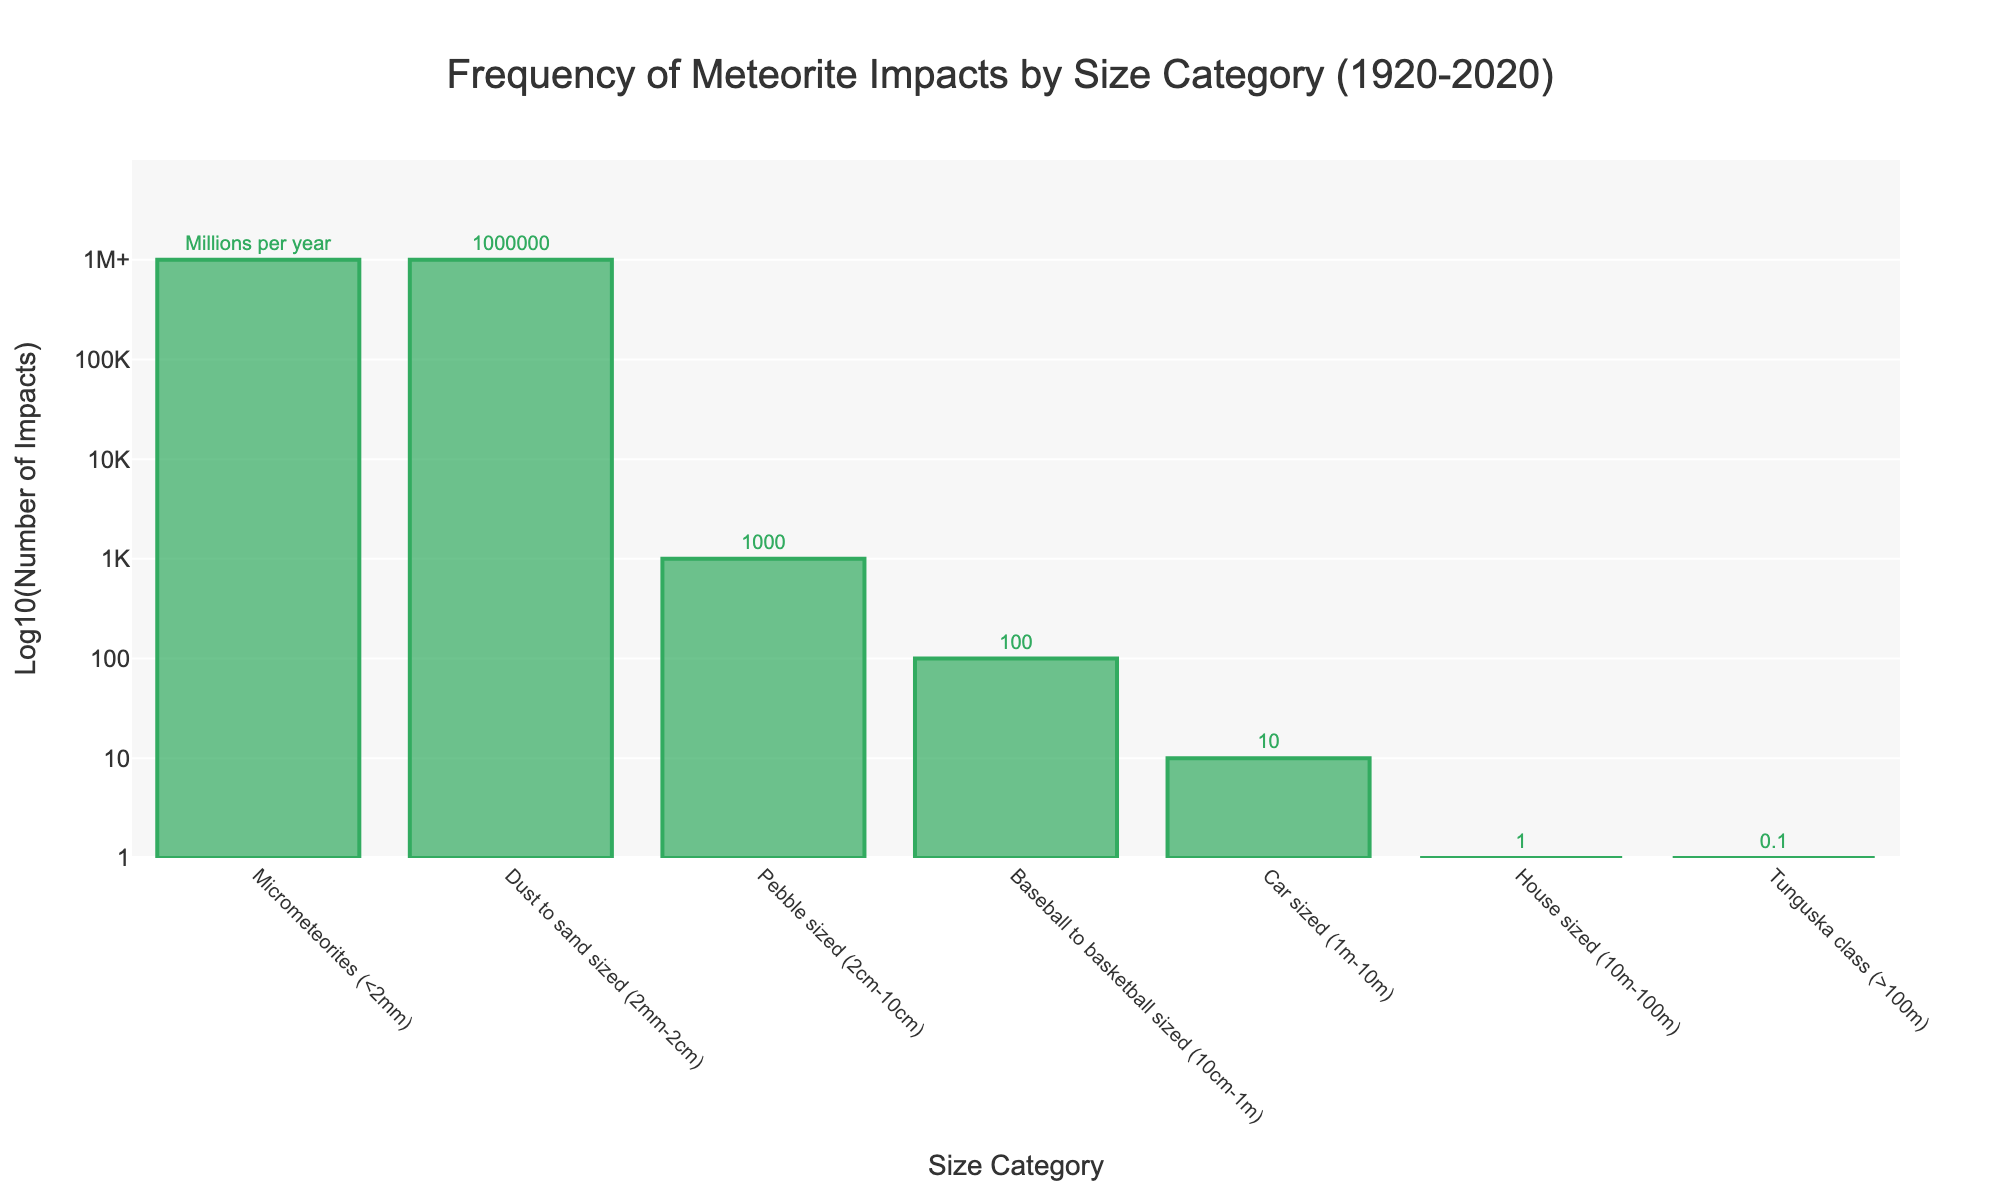What's the most frequent size category of meteorite impacts? The most frequent size category corresponds to the tallest bar in the chart, which represents micrometeorites (<2mm). The chart labels indicate this category experiences occurrences in the millions per year.
Answer: Micrometeorites (<2mm) How does the frequency of car-sized meteorite impacts compare to house-sized impacts? Observing the height and labels of the bars for these categories, car-sized impacts (1m-10m) are represented with approximately 10 occurrences, while house-sized impacts (10m-100m) show about 1 occurrence over the last century.
Answer: Car-sized impacts are 10 times more frequent than house-sized impacts What's the log10 number of impacts for baseball to basketball-sized category? The chart's y-axis uses a logarithmic scale. The bar for baseball to basketball-sized meteorites (10cm-1m) reaches the tick mark corresponding to log10 value of 2, indicating the number of impacts as 100.
Answer: 2 How many more impacts are there for micrometeorites than Tunguska class impacts? Micrometeorites are in the millions per year range, converted to 1,000,000, while Tunguska class (>100m) impacts are around 0.1. The difference is calculated as 1,000,000 - 0.1 = 999,999.9.
Answer: 999,999.9 Which size category experiences the least frequent impacts and what is its log10 value? The category with the least frequent impacts is Tunguska class (>100m), represented by the shortest bar with a log10 value indicated as -1 (0.1) on the y-axis.
Answer: Tunguska class (>100m) with log10 value of -1 Calculate the difference in the log10 values between pebble-sized and car-sized impacts. The log10 value for pebble-sized impacts (2cm-10cm) is 3 (1,000), and for car-sized impacts (1m-10m) it's 1 (10). The difference is calculated as 3 - 1 = 2.
Answer: 2 What is the visual color used for all the bars in the chart? The color of the bars can be observed as green, with variations in shade between the inside and the borders for visual clarity.
Answer: Green How many orders of magnitude more frequent are dust to sand-sized impacts compared to house-sized impacts? Dust to sand-sized impacts (2mm-2cm) have a log10 value of 6 (1,000,000), while house-sized impacts (10m-100m) have a log10 value of 0 (1). The difference in their log10 values indicates they are 6 orders of magnitude more frequent.
Answer: 6 